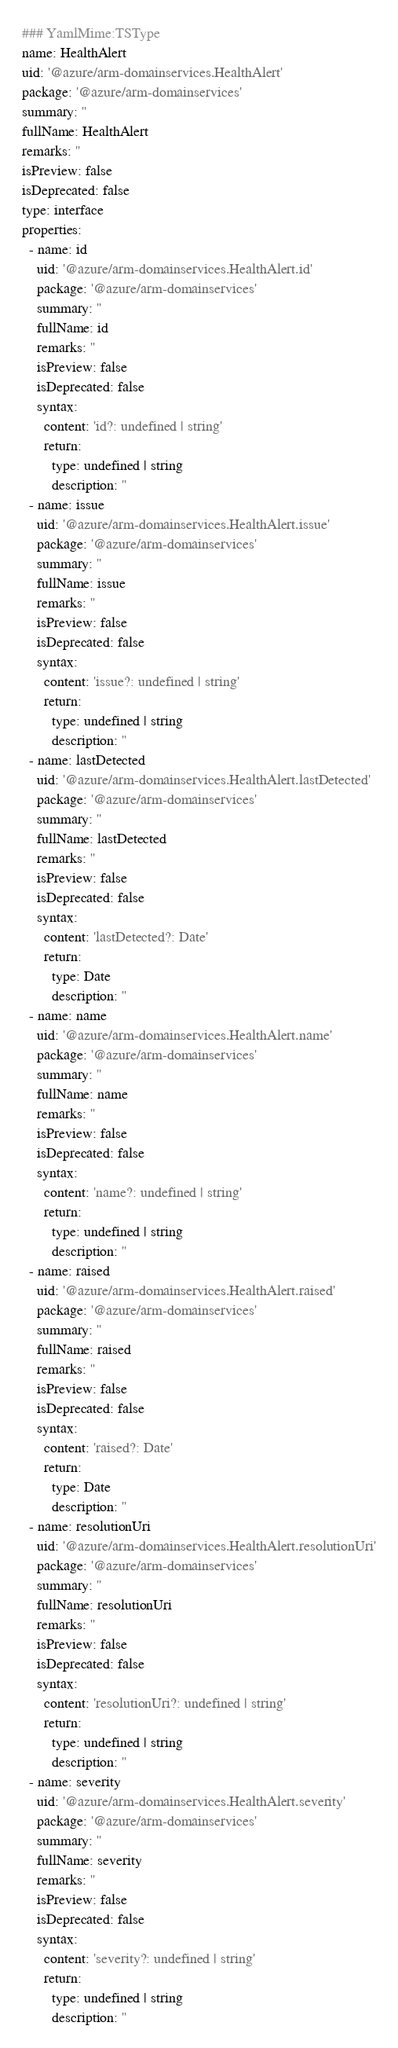Convert code to text. <code><loc_0><loc_0><loc_500><loc_500><_YAML_>### YamlMime:TSType
name: HealthAlert
uid: '@azure/arm-domainservices.HealthAlert'
package: '@azure/arm-domainservices'
summary: ''
fullName: HealthAlert
remarks: ''
isPreview: false
isDeprecated: false
type: interface
properties:
  - name: id
    uid: '@azure/arm-domainservices.HealthAlert.id'
    package: '@azure/arm-domainservices'
    summary: ''
    fullName: id
    remarks: ''
    isPreview: false
    isDeprecated: false
    syntax:
      content: 'id?: undefined | string'
      return:
        type: undefined | string
        description: ''
  - name: issue
    uid: '@azure/arm-domainservices.HealthAlert.issue'
    package: '@azure/arm-domainservices'
    summary: ''
    fullName: issue
    remarks: ''
    isPreview: false
    isDeprecated: false
    syntax:
      content: 'issue?: undefined | string'
      return:
        type: undefined | string
        description: ''
  - name: lastDetected
    uid: '@azure/arm-domainservices.HealthAlert.lastDetected'
    package: '@azure/arm-domainservices'
    summary: ''
    fullName: lastDetected
    remarks: ''
    isPreview: false
    isDeprecated: false
    syntax:
      content: 'lastDetected?: Date'
      return:
        type: Date
        description: ''
  - name: name
    uid: '@azure/arm-domainservices.HealthAlert.name'
    package: '@azure/arm-domainservices'
    summary: ''
    fullName: name
    remarks: ''
    isPreview: false
    isDeprecated: false
    syntax:
      content: 'name?: undefined | string'
      return:
        type: undefined | string
        description: ''
  - name: raised
    uid: '@azure/arm-domainservices.HealthAlert.raised'
    package: '@azure/arm-domainservices'
    summary: ''
    fullName: raised
    remarks: ''
    isPreview: false
    isDeprecated: false
    syntax:
      content: 'raised?: Date'
      return:
        type: Date
        description: ''
  - name: resolutionUri
    uid: '@azure/arm-domainservices.HealthAlert.resolutionUri'
    package: '@azure/arm-domainservices'
    summary: ''
    fullName: resolutionUri
    remarks: ''
    isPreview: false
    isDeprecated: false
    syntax:
      content: 'resolutionUri?: undefined | string'
      return:
        type: undefined | string
        description: ''
  - name: severity
    uid: '@azure/arm-domainservices.HealthAlert.severity'
    package: '@azure/arm-domainservices'
    summary: ''
    fullName: severity
    remarks: ''
    isPreview: false
    isDeprecated: false
    syntax:
      content: 'severity?: undefined | string'
      return:
        type: undefined | string
        description: ''
</code> 